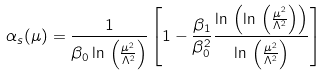<formula> <loc_0><loc_0><loc_500><loc_500>\alpha _ { s } ( \mu ) = \frac { 1 } { \beta _ { 0 } \ln \, \left ( \frac { \mu ^ { 2 } } { \Lambda ^ { 2 } } \right ) } \left [ 1 - \frac { \beta _ { 1 } } { \beta _ { 0 } ^ { 2 } } \frac { \ln \, \left ( \ln \, \left ( \frac { \mu ^ { 2 } } { \Lambda ^ { 2 } } \right ) \right ) } { \ln \, \left ( \frac { \mu ^ { 2 } } { \Lambda ^ { 2 } } \right ) } \right ]</formula> 